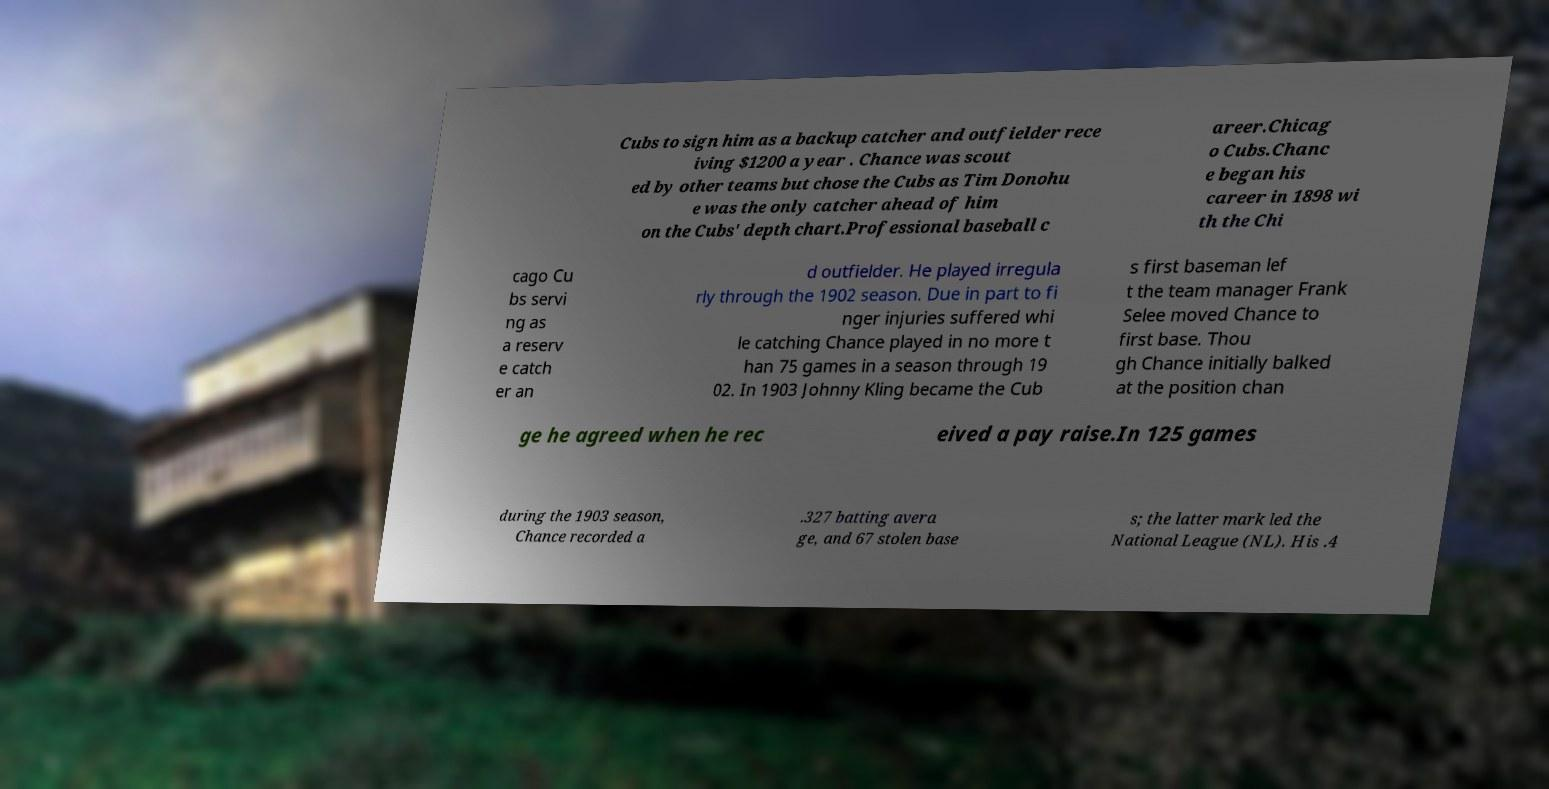Please read and relay the text visible in this image. What does it say? Cubs to sign him as a backup catcher and outfielder rece iving $1200 a year . Chance was scout ed by other teams but chose the Cubs as Tim Donohu e was the only catcher ahead of him on the Cubs' depth chart.Professional baseball c areer.Chicag o Cubs.Chanc e began his career in 1898 wi th the Chi cago Cu bs servi ng as a reserv e catch er an d outfielder. He played irregula rly through the 1902 season. Due in part to fi nger injuries suffered whi le catching Chance played in no more t han 75 games in a season through 19 02. In 1903 Johnny Kling became the Cub s first baseman lef t the team manager Frank Selee moved Chance to first base. Thou gh Chance initially balked at the position chan ge he agreed when he rec eived a pay raise.In 125 games during the 1903 season, Chance recorded a .327 batting avera ge, and 67 stolen base s; the latter mark led the National League (NL). His .4 